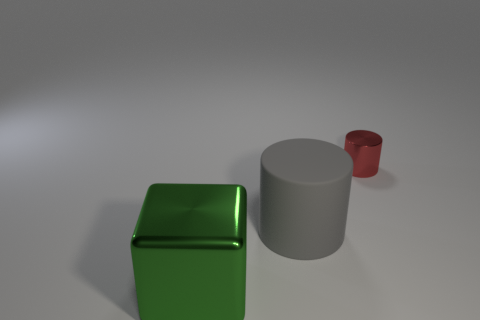Is the number of red metal objects behind the small shiny cylinder the same as the number of small red objects?
Your answer should be compact. No. How many objects are in front of the big cylinder?
Your answer should be compact. 1. How big is the green metallic thing?
Offer a very short reply. Large. The object that is made of the same material as the big green block is what color?
Provide a short and direct response. Red. What number of green metallic things are the same size as the gray matte object?
Keep it short and to the point. 1. Is the cylinder in front of the red metal cylinder made of the same material as the green object?
Provide a succinct answer. No. Is the number of big gray cylinders to the left of the red metallic cylinder less than the number of metallic things?
Your answer should be compact. Yes. What shape is the big object behind the big shiny block?
Offer a very short reply. Cylinder. What shape is the shiny object that is the same size as the gray cylinder?
Ensure brevity in your answer.  Cube. Are there any green objects of the same shape as the tiny red metal thing?
Your answer should be very brief. No. 